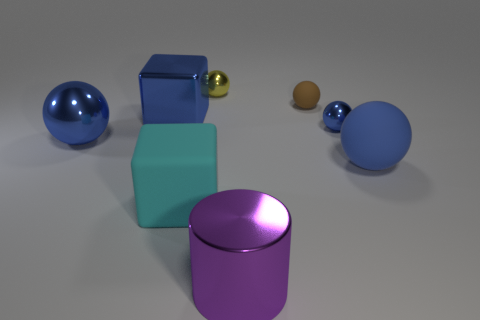There is a large thing that is both right of the cyan rubber cube and to the left of the small brown ball; what is its shape?
Give a very brief answer. Cylinder. How many cylinders have the same material as the large blue cube?
Offer a very short reply. 1. There is a purple thing in front of the blue block; how many small metal spheres are to the right of it?
Keep it short and to the point. 1. The large blue object that is right of the matte object that is in front of the large matte thing that is on the right side of the big purple object is what shape?
Offer a terse response. Sphere. There is a shiny cube that is the same color as the big matte sphere; what size is it?
Provide a succinct answer. Large. What number of things are either big blue metallic balls or large red shiny blocks?
Keep it short and to the point. 1. There is a cylinder that is the same size as the blue rubber object; what is its color?
Provide a succinct answer. Purple. Is the shape of the small blue metal thing the same as the matte thing that is left of the brown object?
Offer a very short reply. No. What number of objects are either tiny spheres that are to the left of the large purple shiny object or blue balls that are in front of the tiny blue metal object?
Give a very brief answer. 3. What is the shape of the big metallic thing that is the same color as the big shiny block?
Offer a terse response. Sphere. 